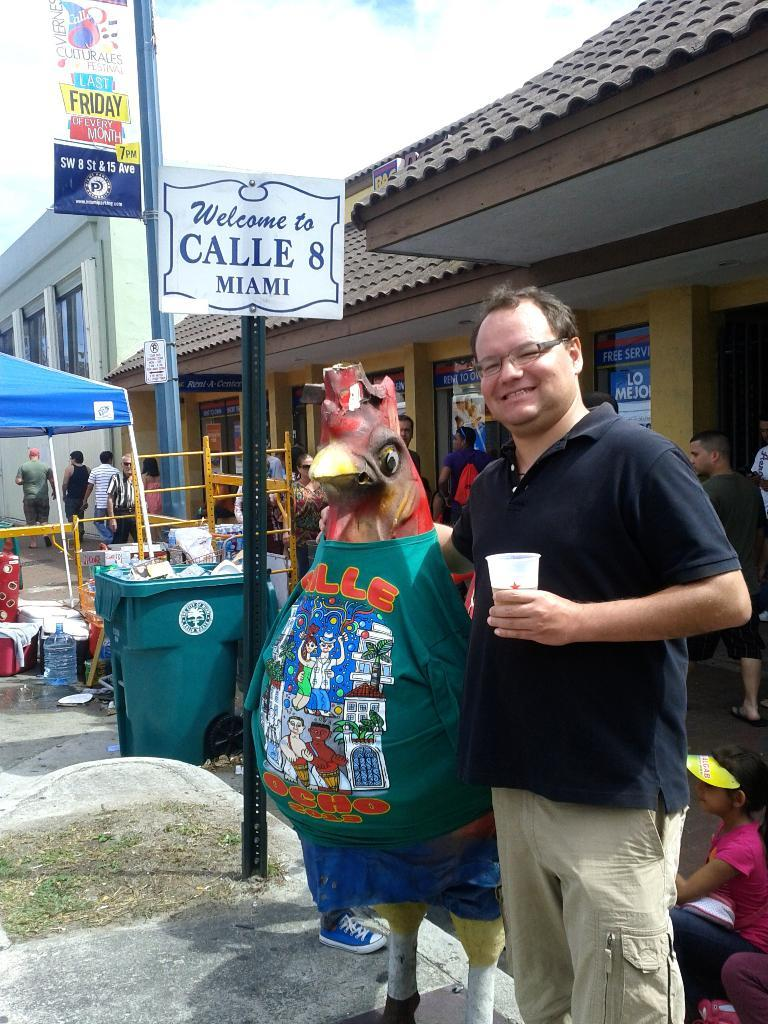Provide a one-sentence caption for the provided image. A man and statue of a chicken standing next to a sign that says Welcome to Calle 8 Miami. 